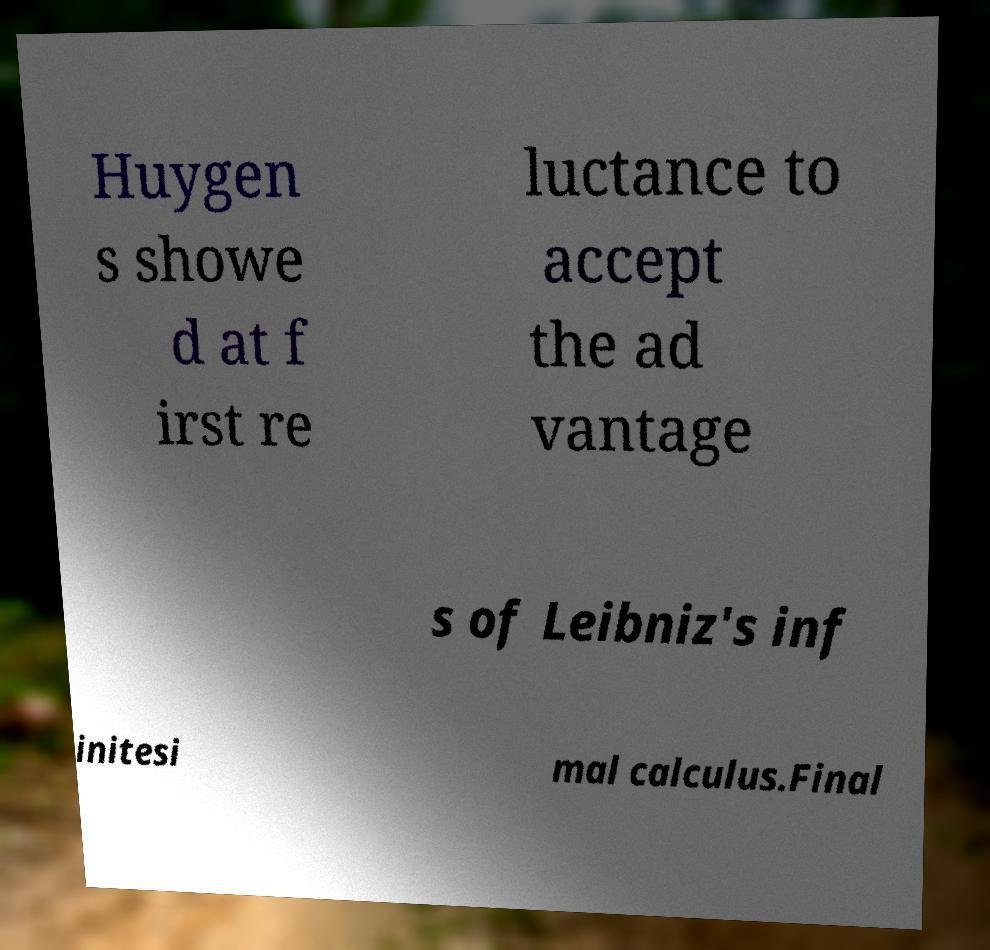There's text embedded in this image that I need extracted. Can you transcribe it verbatim? Huygen s showe d at f irst re luctance to accept the ad vantage s of Leibniz's inf initesi mal calculus.Final 